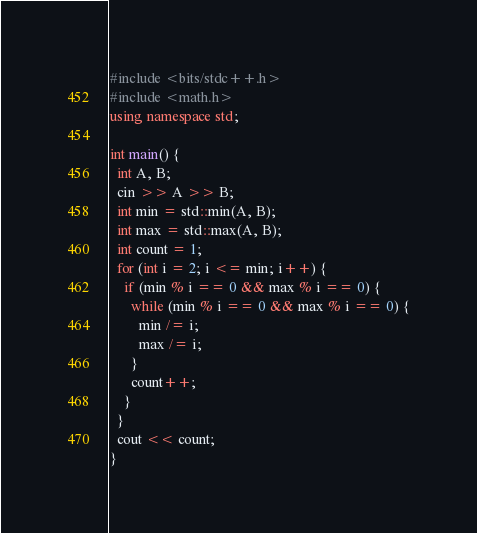<code> <loc_0><loc_0><loc_500><loc_500><_C++_>#include <bits/stdc++.h>
#include <math.h>
using namespace std;

int main() {
  int A, B;
  cin >> A >> B;
  int min = std::min(A, B);
  int max = std::max(A, B);
  int count = 1;
  for (int i = 2; i <= min; i++) {
    if (min % i == 0 && max % i == 0) {
      while (min % i == 0 && max % i == 0) {
        min /= i;
        max /= i;
      }
      count++;
    }
  }
  cout << count;
}
</code> 